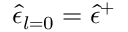<formula> <loc_0><loc_0><loc_500><loc_500>\hat { \epsilon } _ { l = 0 } = \hat { \epsilon } ^ { + }</formula> 